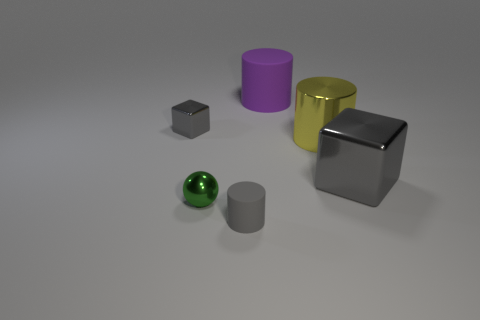What material is the tiny gray thing that is in front of the gray cube that is on the right side of the cube to the left of the small gray matte thing made of? The small gray object in front of the larger gray cube appears to be made of a synthetic material with a slightly reflective surface, which could suggest plastic or coated metal, rather than rubber. 